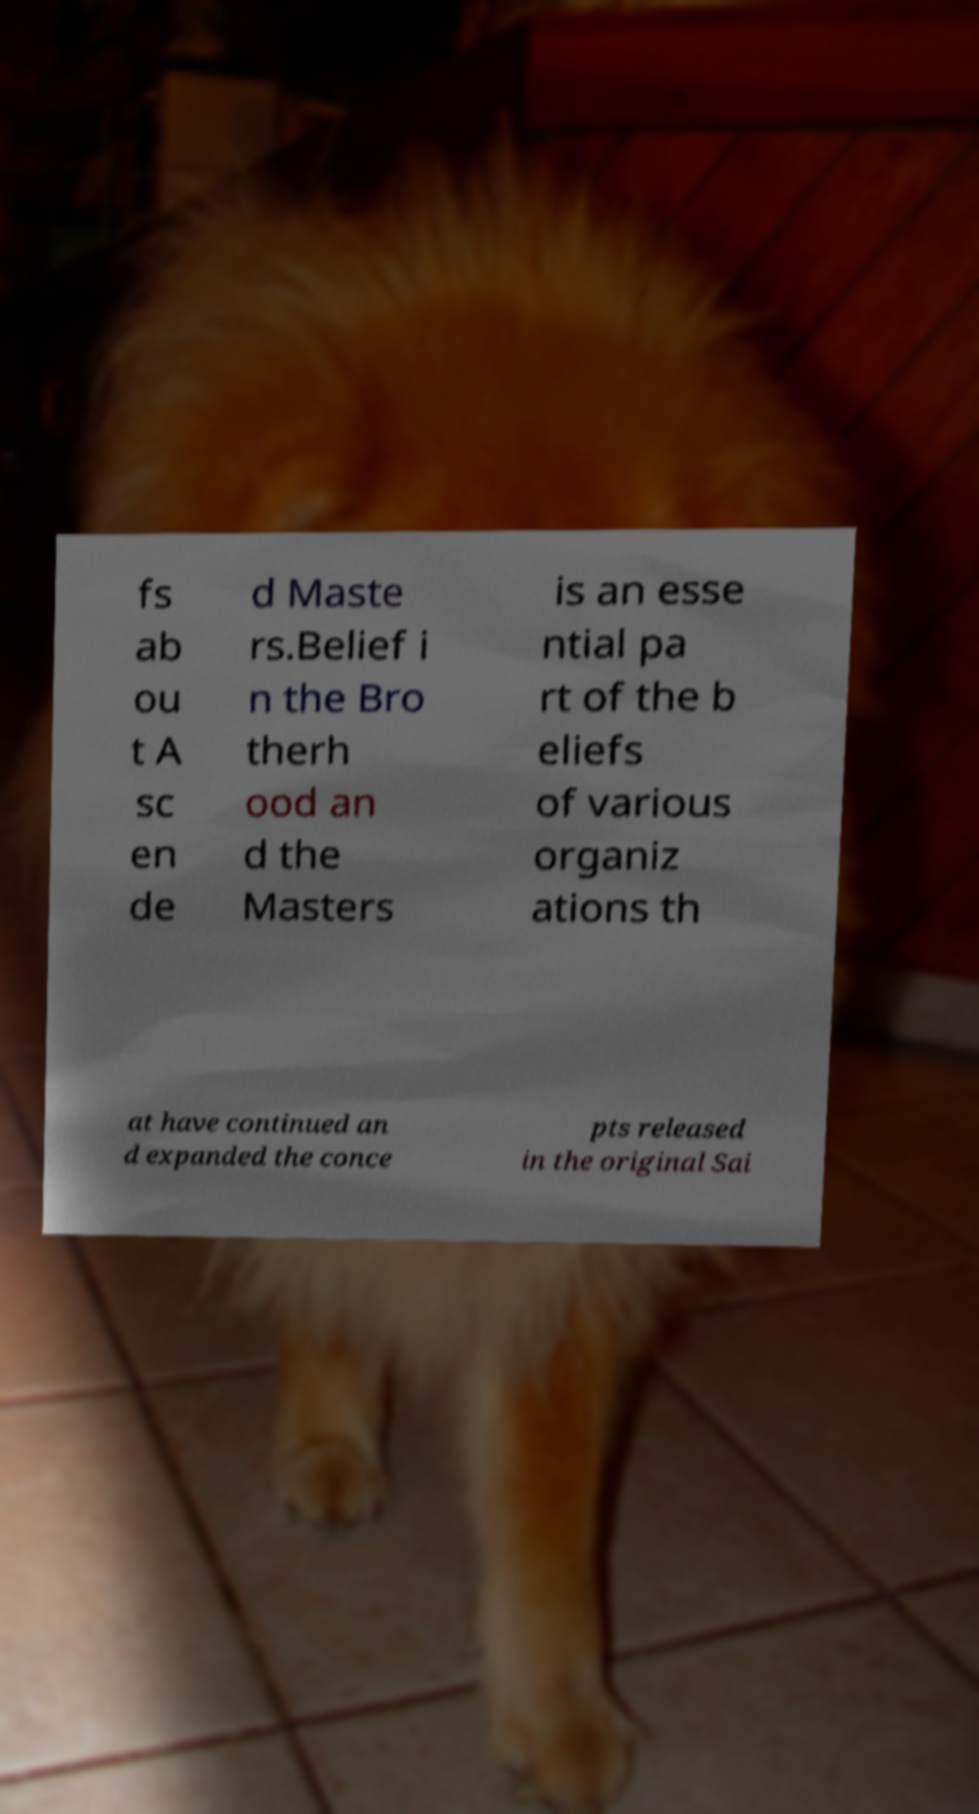Can you read and provide the text displayed in the image?This photo seems to have some interesting text. Can you extract and type it out for me? fs ab ou t A sc en de d Maste rs.Belief i n the Bro therh ood an d the Masters is an esse ntial pa rt of the b eliefs of various organiz ations th at have continued an d expanded the conce pts released in the original Sai 